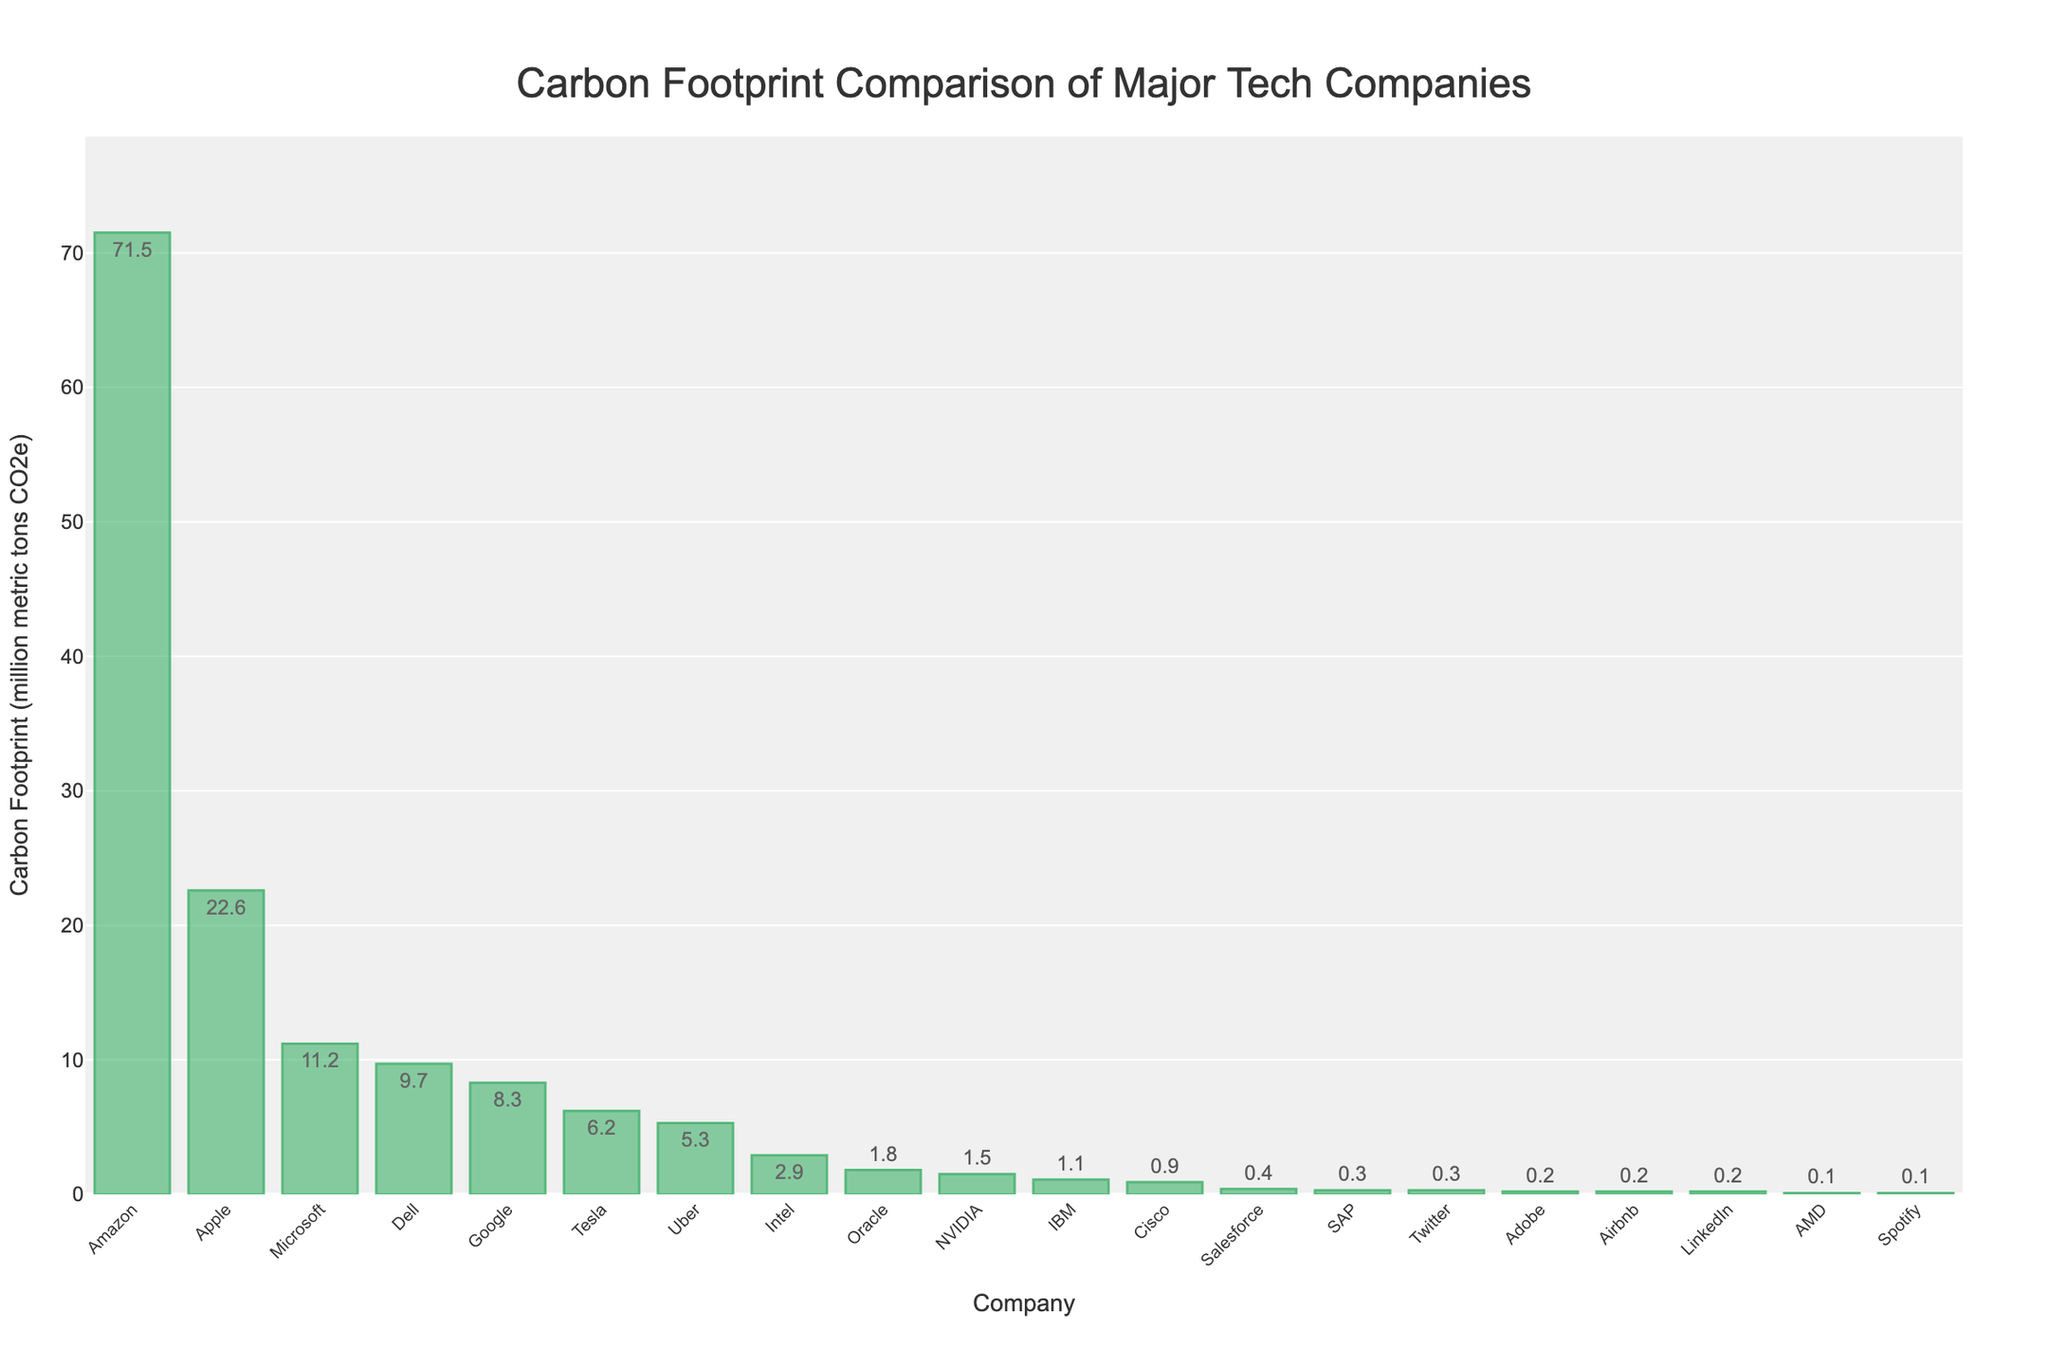Which company has the highest carbon footprint? The bar chart shows that Amazon has the tallest bar, indicating it has the highest carbon footprint among the companies listed.
Answer: Amazon Which two companies in the Software industry have the highest and lowest carbon footprints? By observing the bars labeled under "Software," Microsoft has the highest carbon footprint at 11.2 million metric tons CO2e, and Adobe has the lowest at 0.2 million metric tons CO2e.
Answer: Microsoft (highest), Adobe (lowest) What is the total carbon footprint of companies in the Semiconductors industry? The companies listed under "Semiconductors" are Intel (2.9), AMD (0.1), totaling 2.9 + 0.1 = 3.0 million metric tons CO2e.
Answer: 3.0 How much more is Amazon's carbon footprint compared to Google's? Amazon's carbon footprint is 71.5 million metric tons CO2e, and Google's is 8.3 million metric tons CO2e. The difference is 71.5 - 8.3 = 63.2 million metric tons CO2e.
Answer: 63.2 Which company has a lower carbon footprint: Intel or Uber? The bar for Intel shows 2.9 million metric tons CO2e, whereas Uber has 5.3 million metric tons CO2e. Comparing the two, Intel has a lower carbon footprint.
Answer: Intel What is the average carbon footprint of companies involved in Internet Services and Social Media combined? The companies are Google (8.3) in Internet Services and Twitter (0.3) in Social Media. The average is (8.3 + 0.3) / 2 = 4.3 million metric tons CO2e.
Answer: 4.3 Which industry has the company with the smallest carbon footprint? The company with the smallest carbon footprint is AMD with 0.1 million metric tons CO2e, and it belongs to the Semiconductors industry.
Answer: Semiconductors How does the carbon footprint of Tesla compare to Dell? Tesla's carbon footprint is 6.2 million metric tons CO2e, while Dell's is 9.7 million metric tons CO2e. Tesla's carbon footprint is lower than Dell's.
Answer: Tesla's is lower What is the combined carbon footprint of the top three companies with the highest emissions? The top three companies are Amazon (71.5), Apple (22.6), and Microsoft (11.2). The combined footprint is 71.5 + 22.6 + 11.2 = 105.3 million metric tons CO2e.
Answer: 105.3 What is the range of carbon footprints among the companies listed? The highest carbon footprint is Amazon's at 71.5 million metric tons CO2e, and the lowest is AMD's at 0.1 million metric tons CO2e. The range is 71.5 - 0.1 = 71.4 million metric tons CO2e.
Answer: 71.4 